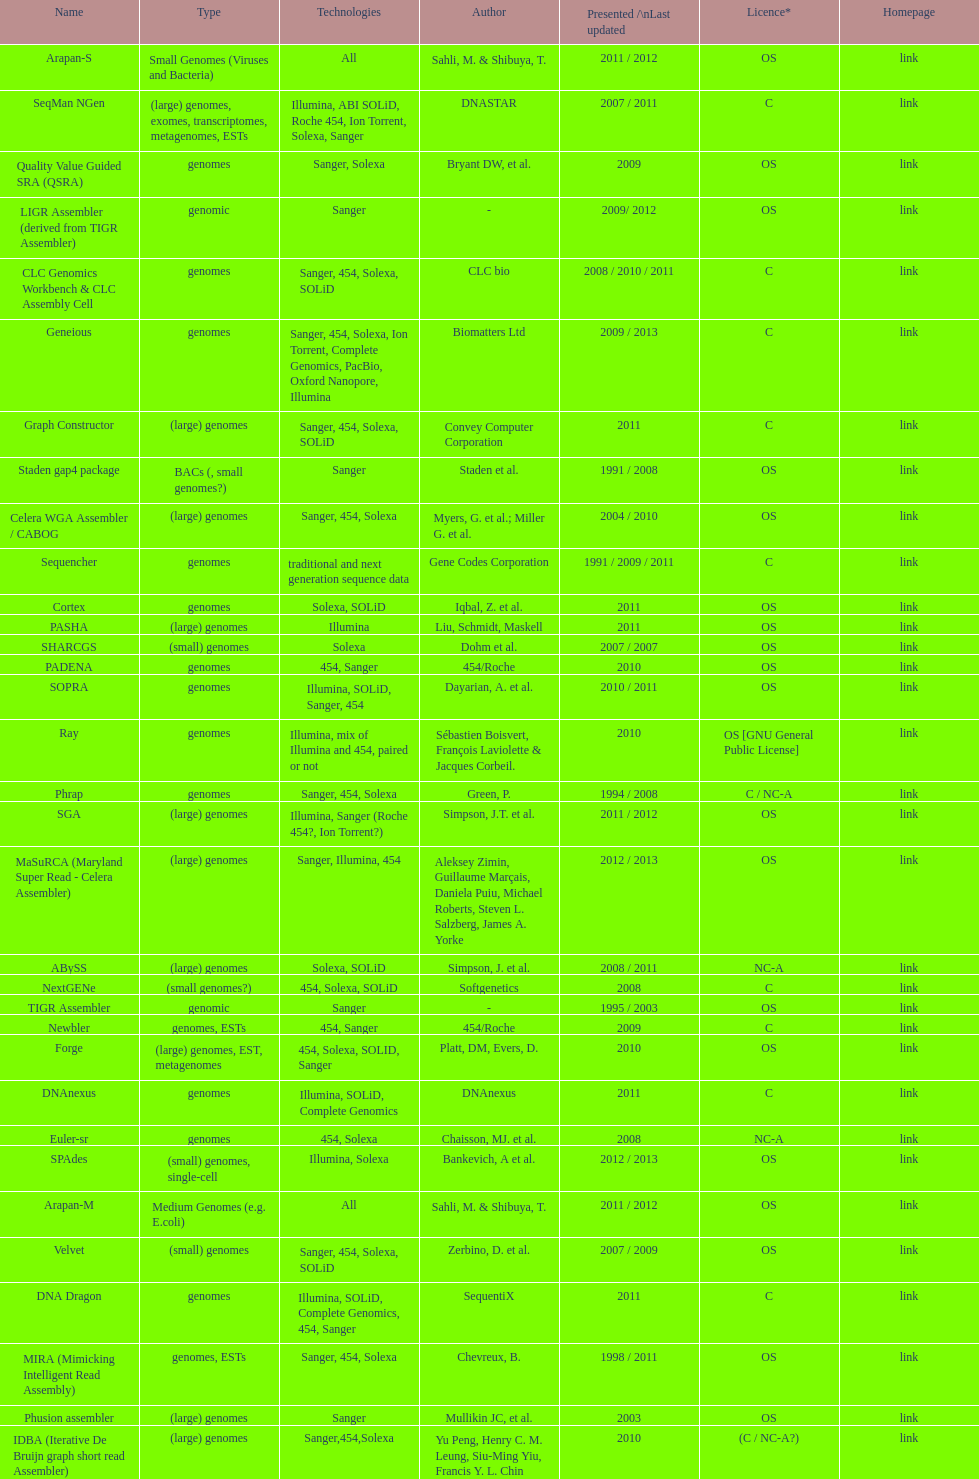What is the newest presentation or updated? DNA Baser. 